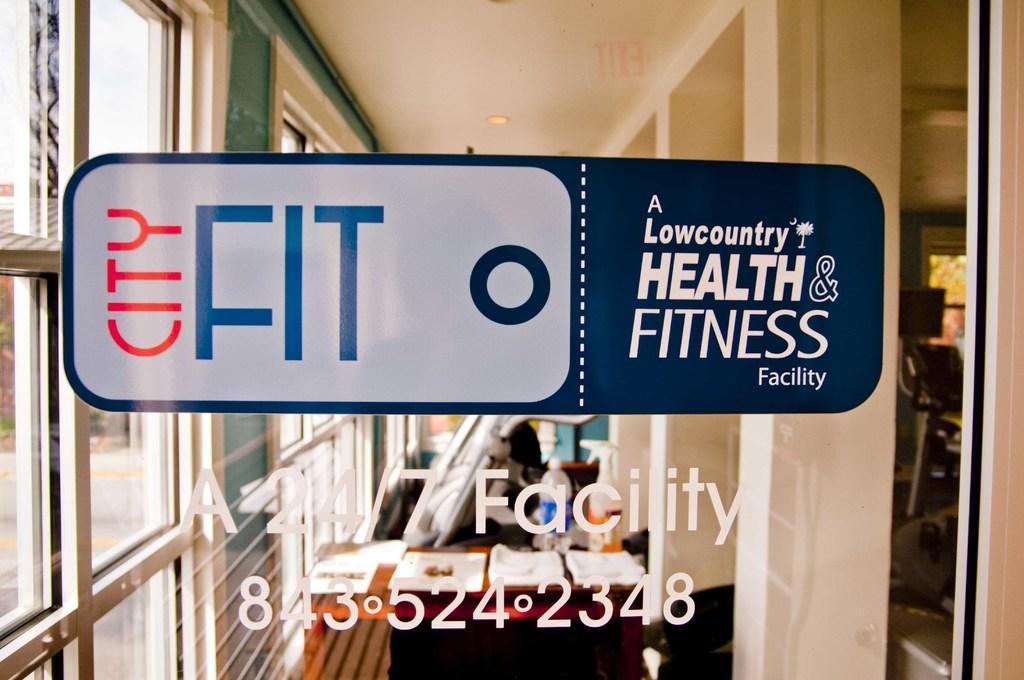Can you describe this image briefly? This image is taken from inside, in this image there are pillars, beside the pillar there is a chair and a table with some objects and water bottle on top of it, behind the table there are a few objects which are not clear. On the left side of the image there is a wall with glass windows. In the foreground of the image there is some text. At the top of the image there is a ceiling. 